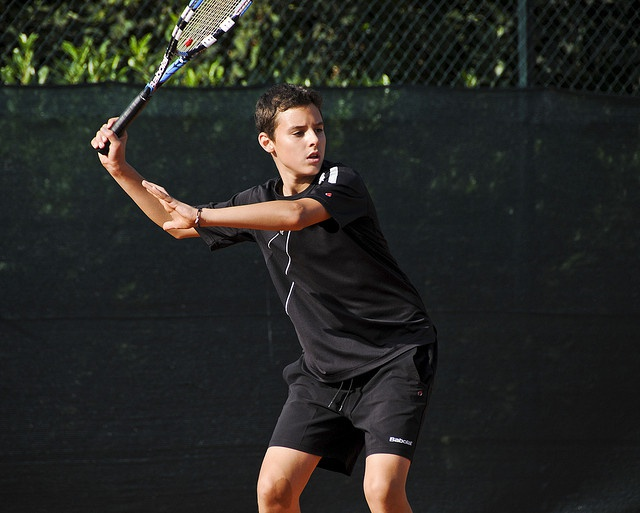Describe the objects in this image and their specific colors. I can see people in black, maroon, tan, and gray tones and tennis racket in black, white, darkgray, and gray tones in this image. 